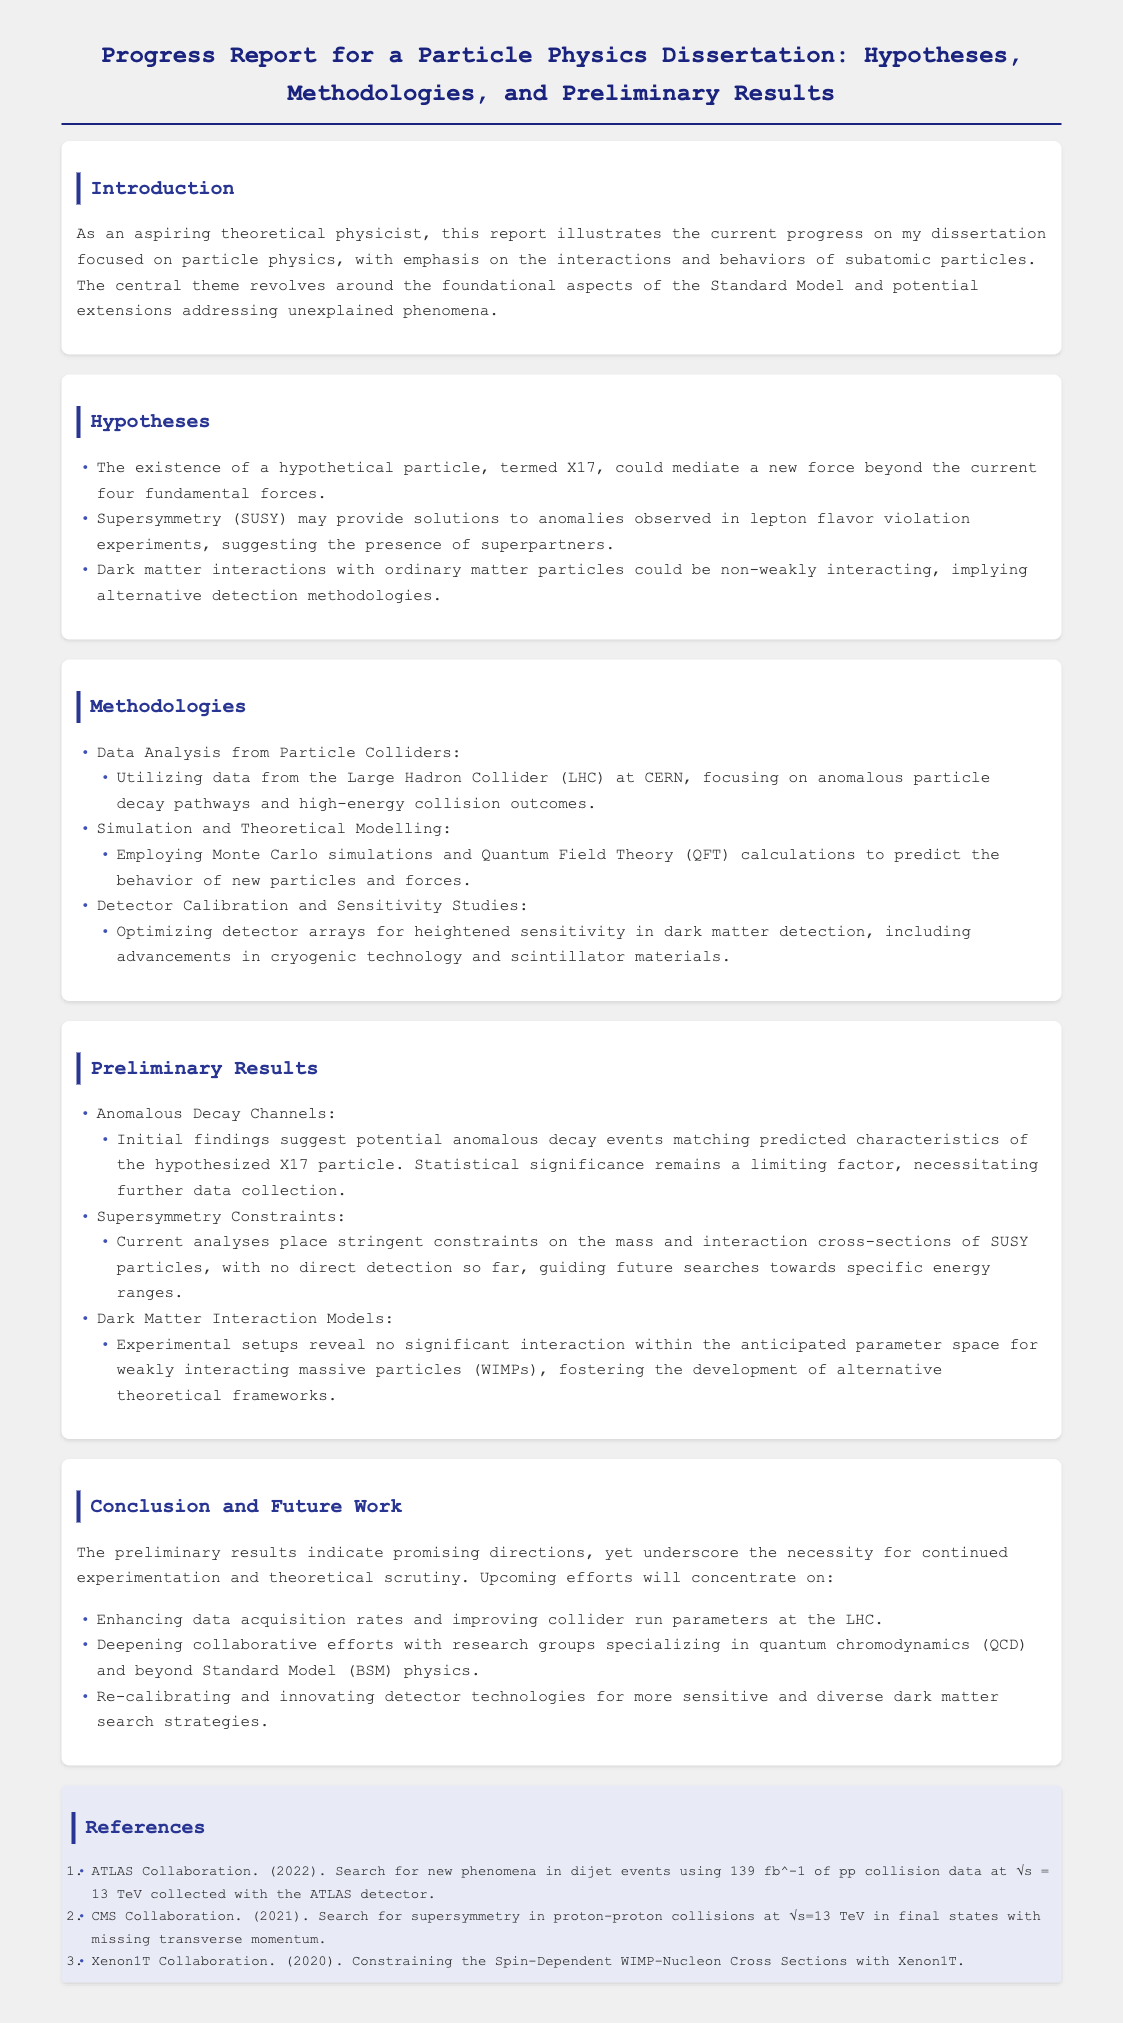What is the central theme of the dissertation? The dissertation focuses on the interactions and behaviors of subatomic particles, emphasizing the Standard Model and potential extensions.
Answer: interactions and behaviors of subatomic particles What is the name of the hypothetical particle proposed? The document mentions a hypothetical particle termed X17 that could mediate a new force.
Answer: X17 What methodology involves the use of data from the Large Hadron Collider? The document outlines data analysis from particle colliders as one methodology employed.
Answer: Data Analysis from Particle Colliders What constraints are currently placed on the mass of SUSY particles? The document notes that current analyses place stringent constraints on the mass and interaction cross-sections of SUSY particles.
Answer: stringent constraints What alternative interaction models are being developed for dark matter? The document states that no significant interaction was found for weakly interacting massive particles, fostering the development of alternative theoretical frameworks.
Answer: alternative theoretical frameworks What will be the focus of upcoming efforts in this research? The document indicates that upcoming efforts will concentrate on enhancing data acquisition rates and improving collider run parameters at the LHC.
Answer: enhancing data acquisition rates How many references are listed in the document? The document lists three references related to particle physics research and collaborations.
Answer: three What is one key area for collaboration mentioned in the report? The report highlights the need for deepening collaborative efforts with research groups specializing in quantum chromodynamics.
Answer: quantum chromodynamics What is the main goal of the detector calibration studies? The document mentions that the goal is to optimize detector arrays for heightened sensitivity in dark matter detection.
Answer: heightened sensitivity in dark matter detection 